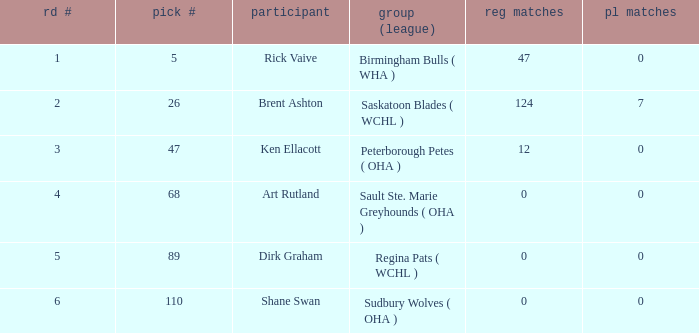How many reg GP for rick vaive in round 1? None. 